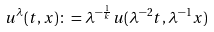Convert formula to latex. <formula><loc_0><loc_0><loc_500><loc_500>u ^ { \lambda } ( t , x ) \colon = \lambda ^ { - \frac { 1 } { k } } u ( \lambda ^ { - 2 } t , \lambda ^ { - 1 } x )</formula> 